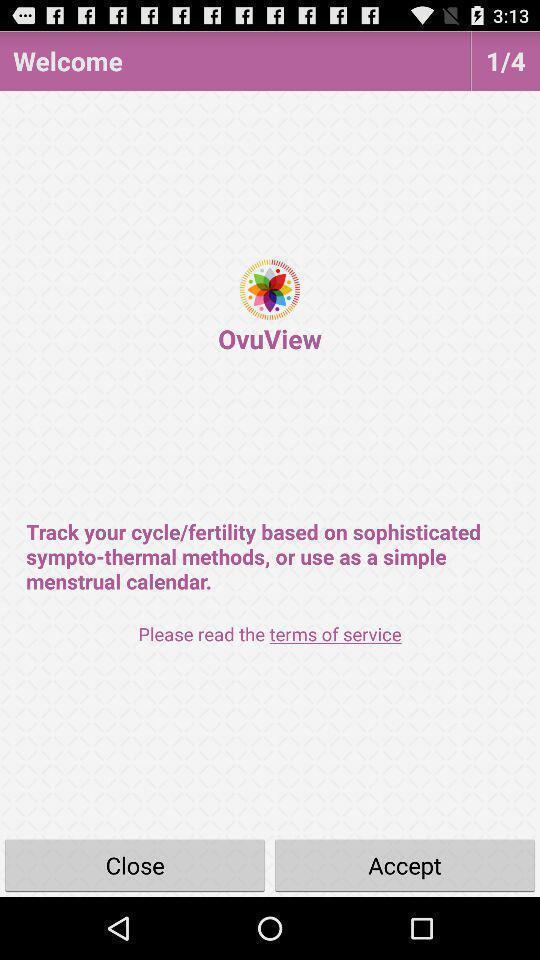Give me a narrative description of this picture. Welcome page to the application with options. 